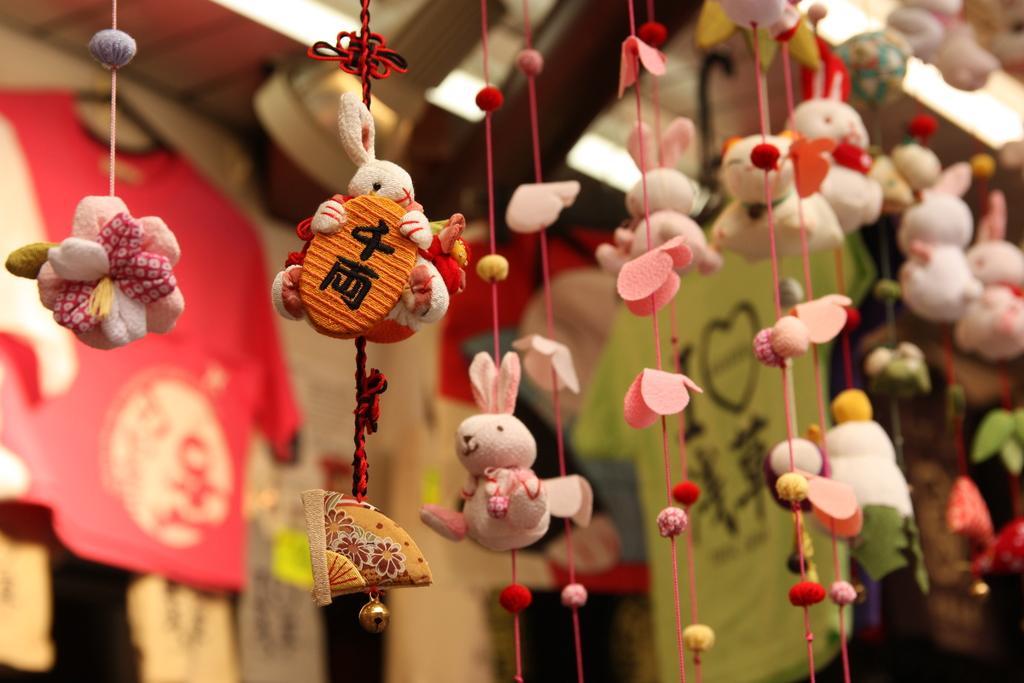How would you summarize this image in a sentence or two? In this picture, we see many toys hanged with the threads. Behind that, we see T-shirts in red and green color. This picture might be clicked in the shop. In the background, it is blurred. 